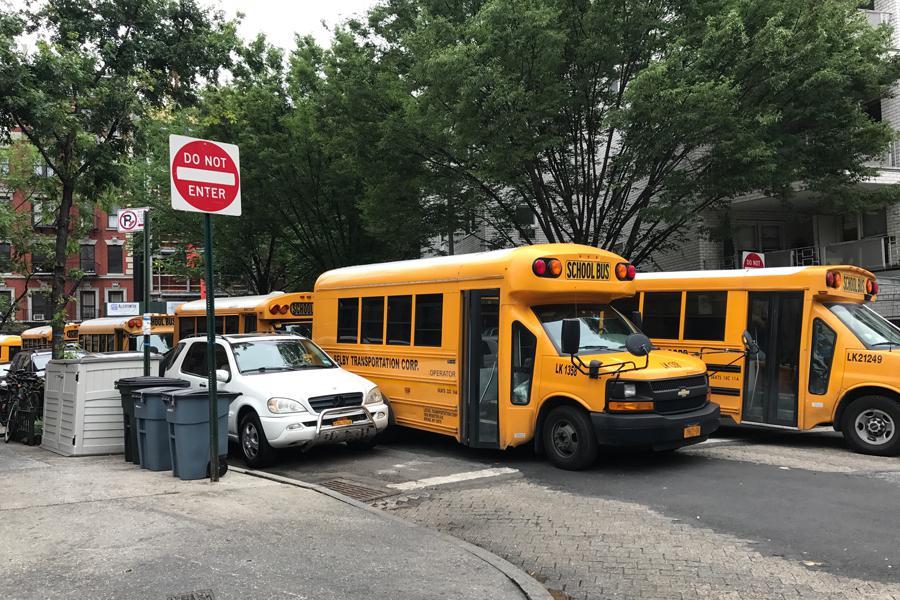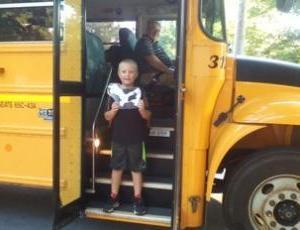The first image is the image on the left, the second image is the image on the right. Considering the images on both sides, is "A bus has its passenger door open." valid? Answer yes or no. Yes. The first image is the image on the left, the second image is the image on the right. For the images displayed, is the sentence "In at least one image there is a short bus facing both right and forward." factually correct? Answer yes or no. Yes. 